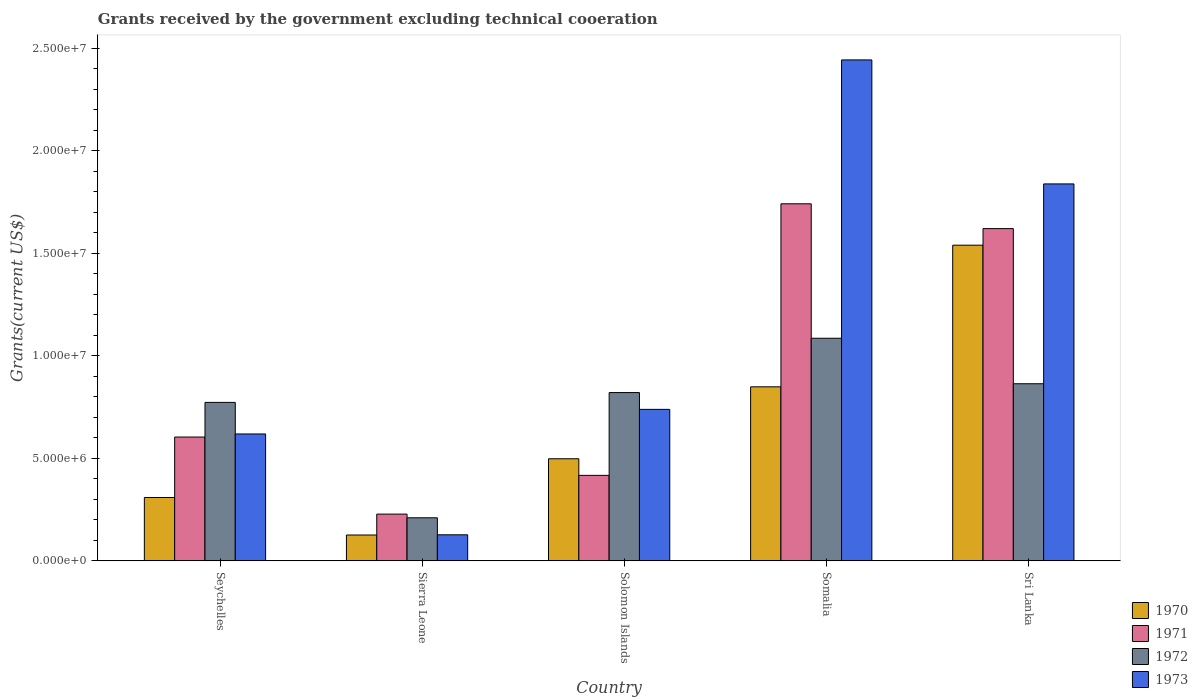How many different coloured bars are there?
Your response must be concise. 4. How many bars are there on the 5th tick from the left?
Ensure brevity in your answer.  4. What is the label of the 2nd group of bars from the left?
Your answer should be very brief. Sierra Leone. In how many cases, is the number of bars for a given country not equal to the number of legend labels?
Offer a terse response. 0. What is the total grants received by the government in 1971 in Sierra Leone?
Make the answer very short. 2.28e+06. Across all countries, what is the maximum total grants received by the government in 1970?
Ensure brevity in your answer.  1.54e+07. Across all countries, what is the minimum total grants received by the government in 1972?
Your response must be concise. 2.10e+06. In which country was the total grants received by the government in 1972 maximum?
Your response must be concise. Somalia. In which country was the total grants received by the government in 1970 minimum?
Your answer should be very brief. Sierra Leone. What is the total total grants received by the government in 1972 in the graph?
Provide a succinct answer. 3.75e+07. What is the difference between the total grants received by the government in 1973 in Seychelles and that in Sierra Leone?
Your answer should be very brief. 4.92e+06. What is the difference between the total grants received by the government in 1973 in Sierra Leone and the total grants received by the government in 1971 in Seychelles?
Make the answer very short. -4.77e+06. What is the average total grants received by the government in 1971 per country?
Offer a very short reply. 9.22e+06. What is the difference between the total grants received by the government of/in 1972 and total grants received by the government of/in 1971 in Sierra Leone?
Your answer should be compact. -1.80e+05. In how many countries, is the total grants received by the government in 1970 greater than 17000000 US$?
Offer a very short reply. 0. What is the ratio of the total grants received by the government in 1973 in Seychelles to that in Solomon Islands?
Your answer should be compact. 0.84. Is the total grants received by the government in 1973 in Solomon Islands less than that in Sri Lanka?
Give a very brief answer. Yes. Is the difference between the total grants received by the government in 1972 in Solomon Islands and Somalia greater than the difference between the total grants received by the government in 1971 in Solomon Islands and Somalia?
Provide a succinct answer. Yes. What is the difference between the highest and the second highest total grants received by the government in 1970?
Keep it short and to the point. 6.91e+06. What is the difference between the highest and the lowest total grants received by the government in 1972?
Your answer should be compact. 8.76e+06. In how many countries, is the total grants received by the government in 1971 greater than the average total grants received by the government in 1971 taken over all countries?
Provide a short and direct response. 2. Is the sum of the total grants received by the government in 1973 in Solomon Islands and Somalia greater than the maximum total grants received by the government in 1972 across all countries?
Give a very brief answer. Yes. Is it the case that in every country, the sum of the total grants received by the government in 1973 and total grants received by the government in 1970 is greater than the sum of total grants received by the government in 1971 and total grants received by the government in 1972?
Offer a terse response. No. What does the 1st bar from the left in Solomon Islands represents?
Your response must be concise. 1970. What does the 3rd bar from the right in Sri Lanka represents?
Keep it short and to the point. 1971. Is it the case that in every country, the sum of the total grants received by the government in 1970 and total grants received by the government in 1971 is greater than the total grants received by the government in 1972?
Provide a short and direct response. Yes. How many countries are there in the graph?
Your response must be concise. 5. How are the legend labels stacked?
Keep it short and to the point. Vertical. What is the title of the graph?
Your answer should be very brief. Grants received by the government excluding technical cooeration. Does "2004" appear as one of the legend labels in the graph?
Your response must be concise. No. What is the label or title of the X-axis?
Make the answer very short. Country. What is the label or title of the Y-axis?
Provide a succinct answer. Grants(current US$). What is the Grants(current US$) in 1970 in Seychelles?
Your response must be concise. 3.09e+06. What is the Grants(current US$) in 1971 in Seychelles?
Give a very brief answer. 6.04e+06. What is the Grants(current US$) of 1972 in Seychelles?
Provide a short and direct response. 7.73e+06. What is the Grants(current US$) in 1973 in Seychelles?
Your answer should be very brief. 6.19e+06. What is the Grants(current US$) in 1970 in Sierra Leone?
Offer a very short reply. 1.26e+06. What is the Grants(current US$) in 1971 in Sierra Leone?
Give a very brief answer. 2.28e+06. What is the Grants(current US$) of 1972 in Sierra Leone?
Provide a short and direct response. 2.10e+06. What is the Grants(current US$) in 1973 in Sierra Leone?
Offer a very short reply. 1.27e+06. What is the Grants(current US$) in 1970 in Solomon Islands?
Your answer should be very brief. 4.98e+06. What is the Grants(current US$) in 1971 in Solomon Islands?
Give a very brief answer. 4.17e+06. What is the Grants(current US$) in 1972 in Solomon Islands?
Provide a succinct answer. 8.21e+06. What is the Grants(current US$) of 1973 in Solomon Islands?
Keep it short and to the point. 7.39e+06. What is the Grants(current US$) of 1970 in Somalia?
Offer a terse response. 8.49e+06. What is the Grants(current US$) of 1971 in Somalia?
Give a very brief answer. 1.74e+07. What is the Grants(current US$) in 1972 in Somalia?
Your answer should be compact. 1.09e+07. What is the Grants(current US$) of 1973 in Somalia?
Your response must be concise. 2.44e+07. What is the Grants(current US$) in 1970 in Sri Lanka?
Your response must be concise. 1.54e+07. What is the Grants(current US$) in 1971 in Sri Lanka?
Make the answer very short. 1.62e+07. What is the Grants(current US$) of 1972 in Sri Lanka?
Make the answer very short. 8.64e+06. What is the Grants(current US$) of 1973 in Sri Lanka?
Make the answer very short. 1.84e+07. Across all countries, what is the maximum Grants(current US$) of 1970?
Your answer should be compact. 1.54e+07. Across all countries, what is the maximum Grants(current US$) in 1971?
Keep it short and to the point. 1.74e+07. Across all countries, what is the maximum Grants(current US$) in 1972?
Your answer should be very brief. 1.09e+07. Across all countries, what is the maximum Grants(current US$) of 1973?
Provide a succinct answer. 2.44e+07. Across all countries, what is the minimum Grants(current US$) of 1970?
Your answer should be very brief. 1.26e+06. Across all countries, what is the minimum Grants(current US$) in 1971?
Your answer should be very brief. 2.28e+06. Across all countries, what is the minimum Grants(current US$) in 1972?
Make the answer very short. 2.10e+06. Across all countries, what is the minimum Grants(current US$) of 1973?
Provide a short and direct response. 1.27e+06. What is the total Grants(current US$) of 1970 in the graph?
Offer a very short reply. 3.32e+07. What is the total Grants(current US$) in 1971 in the graph?
Your response must be concise. 4.61e+07. What is the total Grants(current US$) in 1972 in the graph?
Your response must be concise. 3.75e+07. What is the total Grants(current US$) in 1973 in the graph?
Your answer should be compact. 5.77e+07. What is the difference between the Grants(current US$) of 1970 in Seychelles and that in Sierra Leone?
Give a very brief answer. 1.83e+06. What is the difference between the Grants(current US$) of 1971 in Seychelles and that in Sierra Leone?
Provide a short and direct response. 3.76e+06. What is the difference between the Grants(current US$) of 1972 in Seychelles and that in Sierra Leone?
Ensure brevity in your answer.  5.63e+06. What is the difference between the Grants(current US$) of 1973 in Seychelles and that in Sierra Leone?
Offer a terse response. 4.92e+06. What is the difference between the Grants(current US$) of 1970 in Seychelles and that in Solomon Islands?
Your answer should be very brief. -1.89e+06. What is the difference between the Grants(current US$) of 1971 in Seychelles and that in Solomon Islands?
Your answer should be very brief. 1.87e+06. What is the difference between the Grants(current US$) in 1972 in Seychelles and that in Solomon Islands?
Ensure brevity in your answer.  -4.80e+05. What is the difference between the Grants(current US$) in 1973 in Seychelles and that in Solomon Islands?
Provide a short and direct response. -1.20e+06. What is the difference between the Grants(current US$) in 1970 in Seychelles and that in Somalia?
Give a very brief answer. -5.40e+06. What is the difference between the Grants(current US$) in 1971 in Seychelles and that in Somalia?
Your response must be concise. -1.14e+07. What is the difference between the Grants(current US$) of 1972 in Seychelles and that in Somalia?
Offer a very short reply. -3.13e+06. What is the difference between the Grants(current US$) in 1973 in Seychelles and that in Somalia?
Provide a succinct answer. -1.82e+07. What is the difference between the Grants(current US$) in 1970 in Seychelles and that in Sri Lanka?
Provide a succinct answer. -1.23e+07. What is the difference between the Grants(current US$) of 1971 in Seychelles and that in Sri Lanka?
Offer a very short reply. -1.02e+07. What is the difference between the Grants(current US$) in 1972 in Seychelles and that in Sri Lanka?
Offer a terse response. -9.10e+05. What is the difference between the Grants(current US$) in 1973 in Seychelles and that in Sri Lanka?
Ensure brevity in your answer.  -1.22e+07. What is the difference between the Grants(current US$) in 1970 in Sierra Leone and that in Solomon Islands?
Ensure brevity in your answer.  -3.72e+06. What is the difference between the Grants(current US$) of 1971 in Sierra Leone and that in Solomon Islands?
Provide a succinct answer. -1.89e+06. What is the difference between the Grants(current US$) of 1972 in Sierra Leone and that in Solomon Islands?
Your response must be concise. -6.11e+06. What is the difference between the Grants(current US$) in 1973 in Sierra Leone and that in Solomon Islands?
Make the answer very short. -6.12e+06. What is the difference between the Grants(current US$) of 1970 in Sierra Leone and that in Somalia?
Give a very brief answer. -7.23e+06. What is the difference between the Grants(current US$) of 1971 in Sierra Leone and that in Somalia?
Provide a succinct answer. -1.51e+07. What is the difference between the Grants(current US$) in 1972 in Sierra Leone and that in Somalia?
Your answer should be compact. -8.76e+06. What is the difference between the Grants(current US$) of 1973 in Sierra Leone and that in Somalia?
Make the answer very short. -2.32e+07. What is the difference between the Grants(current US$) in 1970 in Sierra Leone and that in Sri Lanka?
Provide a short and direct response. -1.41e+07. What is the difference between the Grants(current US$) in 1971 in Sierra Leone and that in Sri Lanka?
Your response must be concise. -1.39e+07. What is the difference between the Grants(current US$) of 1972 in Sierra Leone and that in Sri Lanka?
Your answer should be compact. -6.54e+06. What is the difference between the Grants(current US$) of 1973 in Sierra Leone and that in Sri Lanka?
Give a very brief answer. -1.71e+07. What is the difference between the Grants(current US$) of 1970 in Solomon Islands and that in Somalia?
Keep it short and to the point. -3.51e+06. What is the difference between the Grants(current US$) of 1971 in Solomon Islands and that in Somalia?
Offer a very short reply. -1.32e+07. What is the difference between the Grants(current US$) of 1972 in Solomon Islands and that in Somalia?
Make the answer very short. -2.65e+06. What is the difference between the Grants(current US$) in 1973 in Solomon Islands and that in Somalia?
Offer a terse response. -1.70e+07. What is the difference between the Grants(current US$) of 1970 in Solomon Islands and that in Sri Lanka?
Offer a very short reply. -1.04e+07. What is the difference between the Grants(current US$) of 1971 in Solomon Islands and that in Sri Lanka?
Your response must be concise. -1.20e+07. What is the difference between the Grants(current US$) in 1972 in Solomon Islands and that in Sri Lanka?
Offer a terse response. -4.30e+05. What is the difference between the Grants(current US$) of 1973 in Solomon Islands and that in Sri Lanka?
Keep it short and to the point. -1.10e+07. What is the difference between the Grants(current US$) in 1970 in Somalia and that in Sri Lanka?
Ensure brevity in your answer.  -6.91e+06. What is the difference between the Grants(current US$) in 1971 in Somalia and that in Sri Lanka?
Your answer should be very brief. 1.21e+06. What is the difference between the Grants(current US$) of 1972 in Somalia and that in Sri Lanka?
Offer a very short reply. 2.22e+06. What is the difference between the Grants(current US$) in 1973 in Somalia and that in Sri Lanka?
Ensure brevity in your answer.  6.05e+06. What is the difference between the Grants(current US$) in 1970 in Seychelles and the Grants(current US$) in 1971 in Sierra Leone?
Keep it short and to the point. 8.10e+05. What is the difference between the Grants(current US$) in 1970 in Seychelles and the Grants(current US$) in 1972 in Sierra Leone?
Make the answer very short. 9.90e+05. What is the difference between the Grants(current US$) of 1970 in Seychelles and the Grants(current US$) of 1973 in Sierra Leone?
Make the answer very short. 1.82e+06. What is the difference between the Grants(current US$) in 1971 in Seychelles and the Grants(current US$) in 1972 in Sierra Leone?
Ensure brevity in your answer.  3.94e+06. What is the difference between the Grants(current US$) of 1971 in Seychelles and the Grants(current US$) of 1973 in Sierra Leone?
Your response must be concise. 4.77e+06. What is the difference between the Grants(current US$) of 1972 in Seychelles and the Grants(current US$) of 1973 in Sierra Leone?
Provide a succinct answer. 6.46e+06. What is the difference between the Grants(current US$) of 1970 in Seychelles and the Grants(current US$) of 1971 in Solomon Islands?
Your answer should be very brief. -1.08e+06. What is the difference between the Grants(current US$) in 1970 in Seychelles and the Grants(current US$) in 1972 in Solomon Islands?
Your answer should be compact. -5.12e+06. What is the difference between the Grants(current US$) in 1970 in Seychelles and the Grants(current US$) in 1973 in Solomon Islands?
Your answer should be very brief. -4.30e+06. What is the difference between the Grants(current US$) in 1971 in Seychelles and the Grants(current US$) in 1972 in Solomon Islands?
Keep it short and to the point. -2.17e+06. What is the difference between the Grants(current US$) of 1971 in Seychelles and the Grants(current US$) of 1973 in Solomon Islands?
Your response must be concise. -1.35e+06. What is the difference between the Grants(current US$) of 1970 in Seychelles and the Grants(current US$) of 1971 in Somalia?
Provide a succinct answer. -1.43e+07. What is the difference between the Grants(current US$) in 1970 in Seychelles and the Grants(current US$) in 1972 in Somalia?
Keep it short and to the point. -7.77e+06. What is the difference between the Grants(current US$) in 1970 in Seychelles and the Grants(current US$) in 1973 in Somalia?
Your answer should be very brief. -2.14e+07. What is the difference between the Grants(current US$) of 1971 in Seychelles and the Grants(current US$) of 1972 in Somalia?
Provide a succinct answer. -4.82e+06. What is the difference between the Grants(current US$) of 1971 in Seychelles and the Grants(current US$) of 1973 in Somalia?
Your answer should be very brief. -1.84e+07. What is the difference between the Grants(current US$) in 1972 in Seychelles and the Grants(current US$) in 1973 in Somalia?
Make the answer very short. -1.67e+07. What is the difference between the Grants(current US$) of 1970 in Seychelles and the Grants(current US$) of 1971 in Sri Lanka?
Ensure brevity in your answer.  -1.31e+07. What is the difference between the Grants(current US$) in 1970 in Seychelles and the Grants(current US$) in 1972 in Sri Lanka?
Offer a very short reply. -5.55e+06. What is the difference between the Grants(current US$) of 1970 in Seychelles and the Grants(current US$) of 1973 in Sri Lanka?
Give a very brief answer. -1.53e+07. What is the difference between the Grants(current US$) in 1971 in Seychelles and the Grants(current US$) in 1972 in Sri Lanka?
Offer a very short reply. -2.60e+06. What is the difference between the Grants(current US$) of 1971 in Seychelles and the Grants(current US$) of 1973 in Sri Lanka?
Your answer should be compact. -1.24e+07. What is the difference between the Grants(current US$) in 1972 in Seychelles and the Grants(current US$) in 1973 in Sri Lanka?
Offer a terse response. -1.07e+07. What is the difference between the Grants(current US$) in 1970 in Sierra Leone and the Grants(current US$) in 1971 in Solomon Islands?
Give a very brief answer. -2.91e+06. What is the difference between the Grants(current US$) in 1970 in Sierra Leone and the Grants(current US$) in 1972 in Solomon Islands?
Provide a short and direct response. -6.95e+06. What is the difference between the Grants(current US$) in 1970 in Sierra Leone and the Grants(current US$) in 1973 in Solomon Islands?
Give a very brief answer. -6.13e+06. What is the difference between the Grants(current US$) in 1971 in Sierra Leone and the Grants(current US$) in 1972 in Solomon Islands?
Give a very brief answer. -5.93e+06. What is the difference between the Grants(current US$) of 1971 in Sierra Leone and the Grants(current US$) of 1973 in Solomon Islands?
Keep it short and to the point. -5.11e+06. What is the difference between the Grants(current US$) of 1972 in Sierra Leone and the Grants(current US$) of 1973 in Solomon Islands?
Keep it short and to the point. -5.29e+06. What is the difference between the Grants(current US$) of 1970 in Sierra Leone and the Grants(current US$) of 1971 in Somalia?
Offer a very short reply. -1.62e+07. What is the difference between the Grants(current US$) of 1970 in Sierra Leone and the Grants(current US$) of 1972 in Somalia?
Make the answer very short. -9.60e+06. What is the difference between the Grants(current US$) in 1970 in Sierra Leone and the Grants(current US$) in 1973 in Somalia?
Your answer should be very brief. -2.32e+07. What is the difference between the Grants(current US$) of 1971 in Sierra Leone and the Grants(current US$) of 1972 in Somalia?
Make the answer very short. -8.58e+06. What is the difference between the Grants(current US$) in 1971 in Sierra Leone and the Grants(current US$) in 1973 in Somalia?
Offer a very short reply. -2.22e+07. What is the difference between the Grants(current US$) of 1972 in Sierra Leone and the Grants(current US$) of 1973 in Somalia?
Keep it short and to the point. -2.23e+07. What is the difference between the Grants(current US$) in 1970 in Sierra Leone and the Grants(current US$) in 1971 in Sri Lanka?
Offer a terse response. -1.50e+07. What is the difference between the Grants(current US$) of 1970 in Sierra Leone and the Grants(current US$) of 1972 in Sri Lanka?
Ensure brevity in your answer.  -7.38e+06. What is the difference between the Grants(current US$) in 1970 in Sierra Leone and the Grants(current US$) in 1973 in Sri Lanka?
Ensure brevity in your answer.  -1.71e+07. What is the difference between the Grants(current US$) of 1971 in Sierra Leone and the Grants(current US$) of 1972 in Sri Lanka?
Ensure brevity in your answer.  -6.36e+06. What is the difference between the Grants(current US$) in 1971 in Sierra Leone and the Grants(current US$) in 1973 in Sri Lanka?
Your answer should be very brief. -1.61e+07. What is the difference between the Grants(current US$) in 1972 in Sierra Leone and the Grants(current US$) in 1973 in Sri Lanka?
Your answer should be compact. -1.63e+07. What is the difference between the Grants(current US$) in 1970 in Solomon Islands and the Grants(current US$) in 1971 in Somalia?
Offer a terse response. -1.24e+07. What is the difference between the Grants(current US$) in 1970 in Solomon Islands and the Grants(current US$) in 1972 in Somalia?
Ensure brevity in your answer.  -5.88e+06. What is the difference between the Grants(current US$) of 1970 in Solomon Islands and the Grants(current US$) of 1973 in Somalia?
Make the answer very short. -1.95e+07. What is the difference between the Grants(current US$) of 1971 in Solomon Islands and the Grants(current US$) of 1972 in Somalia?
Provide a succinct answer. -6.69e+06. What is the difference between the Grants(current US$) in 1971 in Solomon Islands and the Grants(current US$) in 1973 in Somalia?
Your answer should be compact. -2.03e+07. What is the difference between the Grants(current US$) of 1972 in Solomon Islands and the Grants(current US$) of 1973 in Somalia?
Offer a terse response. -1.62e+07. What is the difference between the Grants(current US$) of 1970 in Solomon Islands and the Grants(current US$) of 1971 in Sri Lanka?
Offer a terse response. -1.12e+07. What is the difference between the Grants(current US$) of 1970 in Solomon Islands and the Grants(current US$) of 1972 in Sri Lanka?
Give a very brief answer. -3.66e+06. What is the difference between the Grants(current US$) in 1970 in Solomon Islands and the Grants(current US$) in 1973 in Sri Lanka?
Give a very brief answer. -1.34e+07. What is the difference between the Grants(current US$) in 1971 in Solomon Islands and the Grants(current US$) in 1972 in Sri Lanka?
Provide a short and direct response. -4.47e+06. What is the difference between the Grants(current US$) of 1971 in Solomon Islands and the Grants(current US$) of 1973 in Sri Lanka?
Keep it short and to the point. -1.42e+07. What is the difference between the Grants(current US$) of 1972 in Solomon Islands and the Grants(current US$) of 1973 in Sri Lanka?
Give a very brief answer. -1.02e+07. What is the difference between the Grants(current US$) of 1970 in Somalia and the Grants(current US$) of 1971 in Sri Lanka?
Make the answer very short. -7.72e+06. What is the difference between the Grants(current US$) in 1970 in Somalia and the Grants(current US$) in 1972 in Sri Lanka?
Make the answer very short. -1.50e+05. What is the difference between the Grants(current US$) in 1970 in Somalia and the Grants(current US$) in 1973 in Sri Lanka?
Offer a terse response. -9.90e+06. What is the difference between the Grants(current US$) of 1971 in Somalia and the Grants(current US$) of 1972 in Sri Lanka?
Provide a short and direct response. 8.78e+06. What is the difference between the Grants(current US$) of 1971 in Somalia and the Grants(current US$) of 1973 in Sri Lanka?
Your response must be concise. -9.70e+05. What is the difference between the Grants(current US$) of 1972 in Somalia and the Grants(current US$) of 1973 in Sri Lanka?
Keep it short and to the point. -7.53e+06. What is the average Grants(current US$) of 1970 per country?
Your answer should be compact. 6.64e+06. What is the average Grants(current US$) in 1971 per country?
Your answer should be compact. 9.22e+06. What is the average Grants(current US$) in 1972 per country?
Your response must be concise. 7.51e+06. What is the average Grants(current US$) of 1973 per country?
Make the answer very short. 1.15e+07. What is the difference between the Grants(current US$) of 1970 and Grants(current US$) of 1971 in Seychelles?
Provide a short and direct response. -2.95e+06. What is the difference between the Grants(current US$) in 1970 and Grants(current US$) in 1972 in Seychelles?
Keep it short and to the point. -4.64e+06. What is the difference between the Grants(current US$) in 1970 and Grants(current US$) in 1973 in Seychelles?
Make the answer very short. -3.10e+06. What is the difference between the Grants(current US$) in 1971 and Grants(current US$) in 1972 in Seychelles?
Give a very brief answer. -1.69e+06. What is the difference between the Grants(current US$) of 1971 and Grants(current US$) of 1973 in Seychelles?
Give a very brief answer. -1.50e+05. What is the difference between the Grants(current US$) of 1972 and Grants(current US$) of 1973 in Seychelles?
Ensure brevity in your answer.  1.54e+06. What is the difference between the Grants(current US$) in 1970 and Grants(current US$) in 1971 in Sierra Leone?
Your answer should be very brief. -1.02e+06. What is the difference between the Grants(current US$) in 1970 and Grants(current US$) in 1972 in Sierra Leone?
Your answer should be very brief. -8.40e+05. What is the difference between the Grants(current US$) of 1971 and Grants(current US$) of 1973 in Sierra Leone?
Provide a short and direct response. 1.01e+06. What is the difference between the Grants(current US$) in 1972 and Grants(current US$) in 1973 in Sierra Leone?
Provide a short and direct response. 8.30e+05. What is the difference between the Grants(current US$) of 1970 and Grants(current US$) of 1971 in Solomon Islands?
Make the answer very short. 8.10e+05. What is the difference between the Grants(current US$) of 1970 and Grants(current US$) of 1972 in Solomon Islands?
Your answer should be compact. -3.23e+06. What is the difference between the Grants(current US$) of 1970 and Grants(current US$) of 1973 in Solomon Islands?
Offer a terse response. -2.41e+06. What is the difference between the Grants(current US$) of 1971 and Grants(current US$) of 1972 in Solomon Islands?
Offer a terse response. -4.04e+06. What is the difference between the Grants(current US$) in 1971 and Grants(current US$) in 1973 in Solomon Islands?
Keep it short and to the point. -3.22e+06. What is the difference between the Grants(current US$) of 1972 and Grants(current US$) of 1973 in Solomon Islands?
Your answer should be very brief. 8.20e+05. What is the difference between the Grants(current US$) of 1970 and Grants(current US$) of 1971 in Somalia?
Keep it short and to the point. -8.93e+06. What is the difference between the Grants(current US$) of 1970 and Grants(current US$) of 1972 in Somalia?
Offer a terse response. -2.37e+06. What is the difference between the Grants(current US$) of 1970 and Grants(current US$) of 1973 in Somalia?
Provide a succinct answer. -1.60e+07. What is the difference between the Grants(current US$) of 1971 and Grants(current US$) of 1972 in Somalia?
Your response must be concise. 6.56e+06. What is the difference between the Grants(current US$) in 1971 and Grants(current US$) in 1973 in Somalia?
Your answer should be very brief. -7.02e+06. What is the difference between the Grants(current US$) in 1972 and Grants(current US$) in 1973 in Somalia?
Offer a terse response. -1.36e+07. What is the difference between the Grants(current US$) in 1970 and Grants(current US$) in 1971 in Sri Lanka?
Provide a succinct answer. -8.10e+05. What is the difference between the Grants(current US$) in 1970 and Grants(current US$) in 1972 in Sri Lanka?
Provide a succinct answer. 6.76e+06. What is the difference between the Grants(current US$) in 1970 and Grants(current US$) in 1973 in Sri Lanka?
Your response must be concise. -2.99e+06. What is the difference between the Grants(current US$) in 1971 and Grants(current US$) in 1972 in Sri Lanka?
Provide a short and direct response. 7.57e+06. What is the difference between the Grants(current US$) in 1971 and Grants(current US$) in 1973 in Sri Lanka?
Your response must be concise. -2.18e+06. What is the difference between the Grants(current US$) in 1972 and Grants(current US$) in 1973 in Sri Lanka?
Give a very brief answer. -9.75e+06. What is the ratio of the Grants(current US$) in 1970 in Seychelles to that in Sierra Leone?
Offer a very short reply. 2.45. What is the ratio of the Grants(current US$) in 1971 in Seychelles to that in Sierra Leone?
Your answer should be very brief. 2.65. What is the ratio of the Grants(current US$) of 1972 in Seychelles to that in Sierra Leone?
Offer a terse response. 3.68. What is the ratio of the Grants(current US$) of 1973 in Seychelles to that in Sierra Leone?
Your response must be concise. 4.87. What is the ratio of the Grants(current US$) of 1970 in Seychelles to that in Solomon Islands?
Your answer should be very brief. 0.62. What is the ratio of the Grants(current US$) of 1971 in Seychelles to that in Solomon Islands?
Your response must be concise. 1.45. What is the ratio of the Grants(current US$) in 1972 in Seychelles to that in Solomon Islands?
Your answer should be compact. 0.94. What is the ratio of the Grants(current US$) in 1973 in Seychelles to that in Solomon Islands?
Offer a very short reply. 0.84. What is the ratio of the Grants(current US$) of 1970 in Seychelles to that in Somalia?
Keep it short and to the point. 0.36. What is the ratio of the Grants(current US$) of 1971 in Seychelles to that in Somalia?
Ensure brevity in your answer.  0.35. What is the ratio of the Grants(current US$) of 1972 in Seychelles to that in Somalia?
Your response must be concise. 0.71. What is the ratio of the Grants(current US$) in 1973 in Seychelles to that in Somalia?
Make the answer very short. 0.25. What is the ratio of the Grants(current US$) in 1970 in Seychelles to that in Sri Lanka?
Provide a short and direct response. 0.2. What is the ratio of the Grants(current US$) of 1971 in Seychelles to that in Sri Lanka?
Offer a terse response. 0.37. What is the ratio of the Grants(current US$) of 1972 in Seychelles to that in Sri Lanka?
Make the answer very short. 0.89. What is the ratio of the Grants(current US$) of 1973 in Seychelles to that in Sri Lanka?
Make the answer very short. 0.34. What is the ratio of the Grants(current US$) of 1970 in Sierra Leone to that in Solomon Islands?
Make the answer very short. 0.25. What is the ratio of the Grants(current US$) of 1971 in Sierra Leone to that in Solomon Islands?
Your answer should be compact. 0.55. What is the ratio of the Grants(current US$) in 1972 in Sierra Leone to that in Solomon Islands?
Your answer should be compact. 0.26. What is the ratio of the Grants(current US$) of 1973 in Sierra Leone to that in Solomon Islands?
Provide a short and direct response. 0.17. What is the ratio of the Grants(current US$) in 1970 in Sierra Leone to that in Somalia?
Your response must be concise. 0.15. What is the ratio of the Grants(current US$) in 1971 in Sierra Leone to that in Somalia?
Ensure brevity in your answer.  0.13. What is the ratio of the Grants(current US$) of 1972 in Sierra Leone to that in Somalia?
Give a very brief answer. 0.19. What is the ratio of the Grants(current US$) of 1973 in Sierra Leone to that in Somalia?
Ensure brevity in your answer.  0.05. What is the ratio of the Grants(current US$) in 1970 in Sierra Leone to that in Sri Lanka?
Give a very brief answer. 0.08. What is the ratio of the Grants(current US$) in 1971 in Sierra Leone to that in Sri Lanka?
Keep it short and to the point. 0.14. What is the ratio of the Grants(current US$) in 1972 in Sierra Leone to that in Sri Lanka?
Give a very brief answer. 0.24. What is the ratio of the Grants(current US$) of 1973 in Sierra Leone to that in Sri Lanka?
Make the answer very short. 0.07. What is the ratio of the Grants(current US$) of 1970 in Solomon Islands to that in Somalia?
Your answer should be very brief. 0.59. What is the ratio of the Grants(current US$) in 1971 in Solomon Islands to that in Somalia?
Ensure brevity in your answer.  0.24. What is the ratio of the Grants(current US$) of 1972 in Solomon Islands to that in Somalia?
Keep it short and to the point. 0.76. What is the ratio of the Grants(current US$) in 1973 in Solomon Islands to that in Somalia?
Offer a terse response. 0.3. What is the ratio of the Grants(current US$) of 1970 in Solomon Islands to that in Sri Lanka?
Your answer should be very brief. 0.32. What is the ratio of the Grants(current US$) in 1971 in Solomon Islands to that in Sri Lanka?
Make the answer very short. 0.26. What is the ratio of the Grants(current US$) of 1972 in Solomon Islands to that in Sri Lanka?
Make the answer very short. 0.95. What is the ratio of the Grants(current US$) of 1973 in Solomon Islands to that in Sri Lanka?
Offer a very short reply. 0.4. What is the ratio of the Grants(current US$) of 1970 in Somalia to that in Sri Lanka?
Ensure brevity in your answer.  0.55. What is the ratio of the Grants(current US$) of 1971 in Somalia to that in Sri Lanka?
Your answer should be very brief. 1.07. What is the ratio of the Grants(current US$) in 1972 in Somalia to that in Sri Lanka?
Your answer should be compact. 1.26. What is the ratio of the Grants(current US$) in 1973 in Somalia to that in Sri Lanka?
Provide a short and direct response. 1.33. What is the difference between the highest and the second highest Grants(current US$) in 1970?
Offer a very short reply. 6.91e+06. What is the difference between the highest and the second highest Grants(current US$) in 1971?
Your answer should be very brief. 1.21e+06. What is the difference between the highest and the second highest Grants(current US$) in 1972?
Make the answer very short. 2.22e+06. What is the difference between the highest and the second highest Grants(current US$) in 1973?
Ensure brevity in your answer.  6.05e+06. What is the difference between the highest and the lowest Grants(current US$) in 1970?
Provide a succinct answer. 1.41e+07. What is the difference between the highest and the lowest Grants(current US$) in 1971?
Offer a very short reply. 1.51e+07. What is the difference between the highest and the lowest Grants(current US$) of 1972?
Give a very brief answer. 8.76e+06. What is the difference between the highest and the lowest Grants(current US$) of 1973?
Make the answer very short. 2.32e+07. 